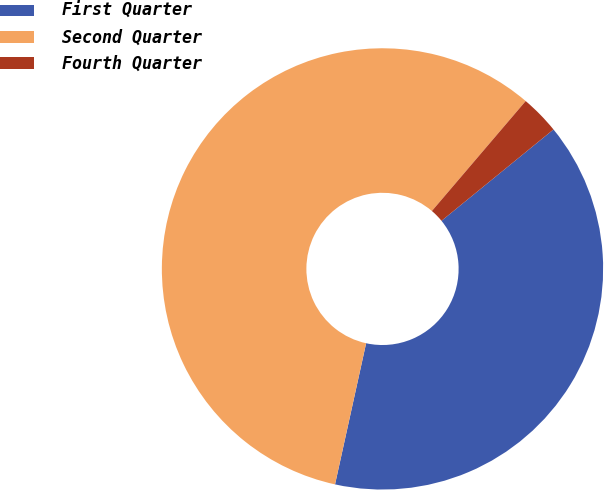Convert chart to OTSL. <chart><loc_0><loc_0><loc_500><loc_500><pie_chart><fcel>First Quarter<fcel>Second Quarter<fcel>Fourth Quarter<nl><fcel>39.34%<fcel>57.79%<fcel>2.87%<nl></chart> 